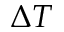<formula> <loc_0><loc_0><loc_500><loc_500>\Delta { T }</formula> 